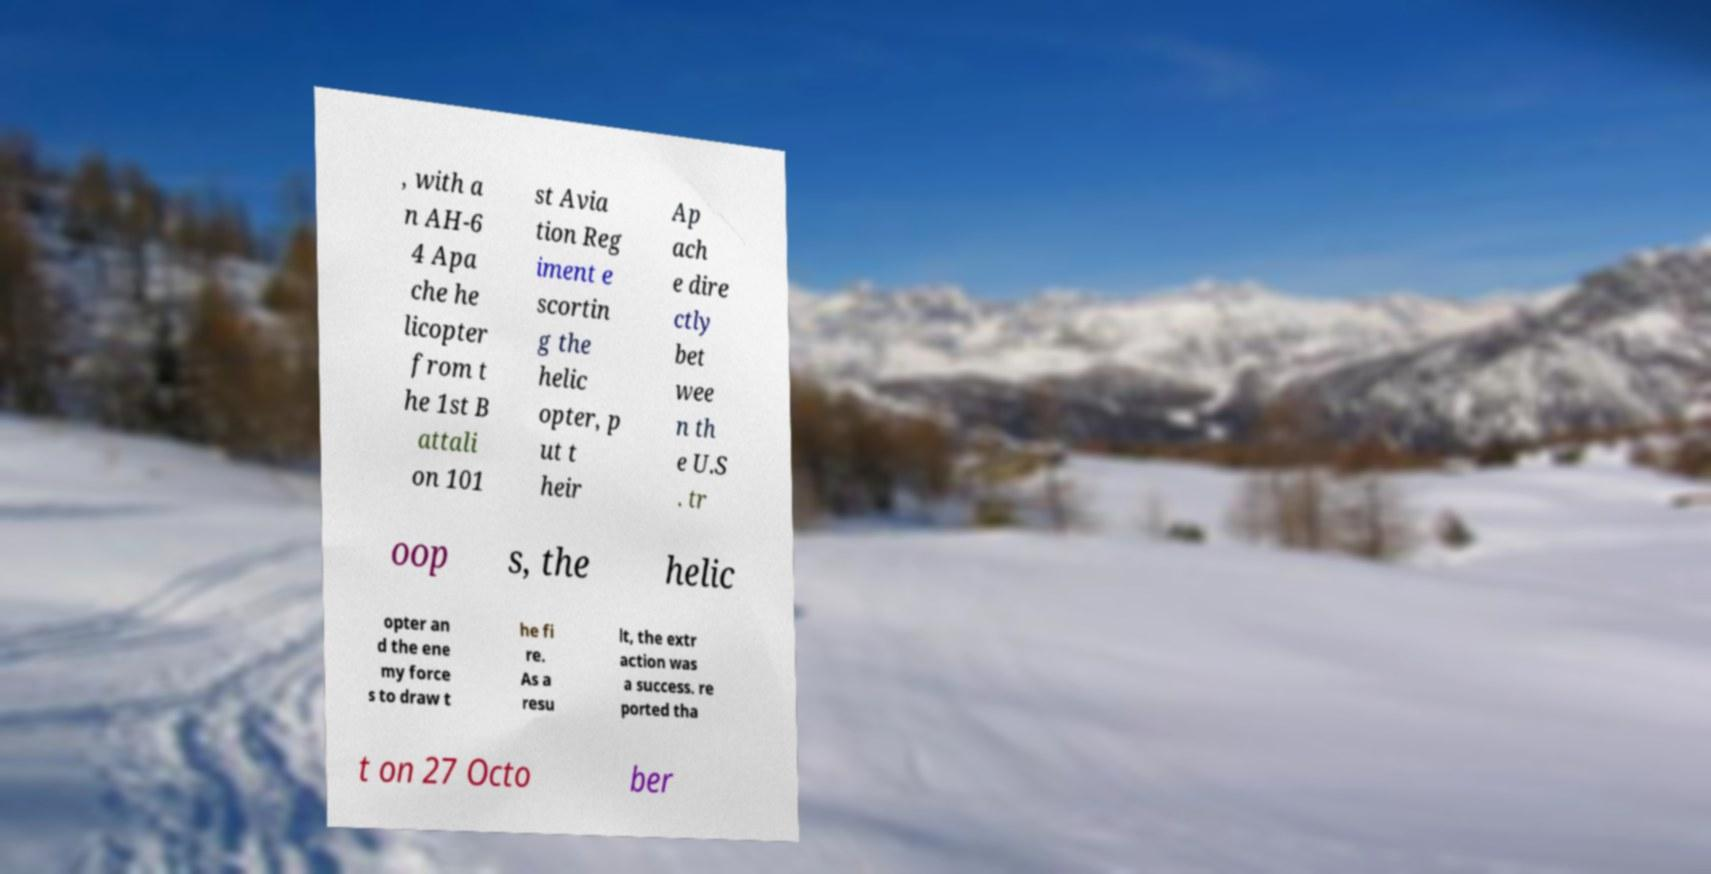What messages or text are displayed in this image? I need them in a readable, typed format. , with a n AH-6 4 Apa che he licopter from t he 1st B attali on 101 st Avia tion Reg iment e scortin g the helic opter, p ut t heir Ap ach e dire ctly bet wee n th e U.S . tr oop s, the helic opter an d the ene my force s to draw t he fi re. As a resu lt, the extr action was a success. re ported tha t on 27 Octo ber 